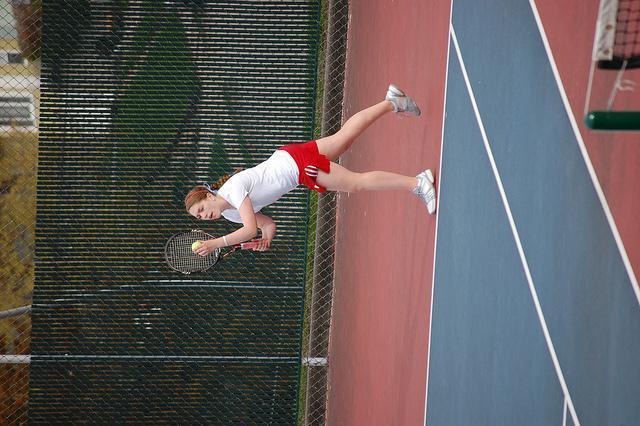How many benches are there?
Give a very brief answer. 0. 